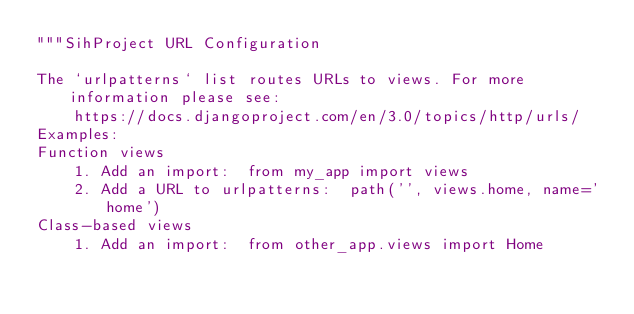Convert code to text. <code><loc_0><loc_0><loc_500><loc_500><_Python_>"""SihProject URL Configuration

The `urlpatterns` list routes URLs to views. For more information please see:
    https://docs.djangoproject.com/en/3.0/topics/http/urls/
Examples:
Function views
    1. Add an import:  from my_app import views
    2. Add a URL to urlpatterns:  path('', views.home, name='home')
Class-based views
    1. Add an import:  from other_app.views import Home</code> 